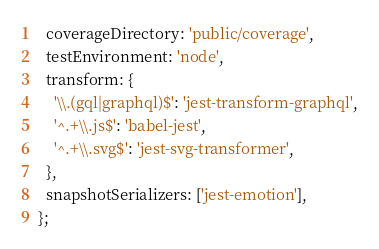<code> <loc_0><loc_0><loc_500><loc_500><_JavaScript_>  coverageDirectory: 'public/coverage',
  testEnvironment: 'node',
  transform: {
    '\\.(gql|graphql)$': 'jest-transform-graphql',
    '^.+\\.js$': 'babel-jest',
    '^.+\\.svg$': 'jest-svg-transformer',
  },
  snapshotSerializers: ['jest-emotion'],
};
</code> 